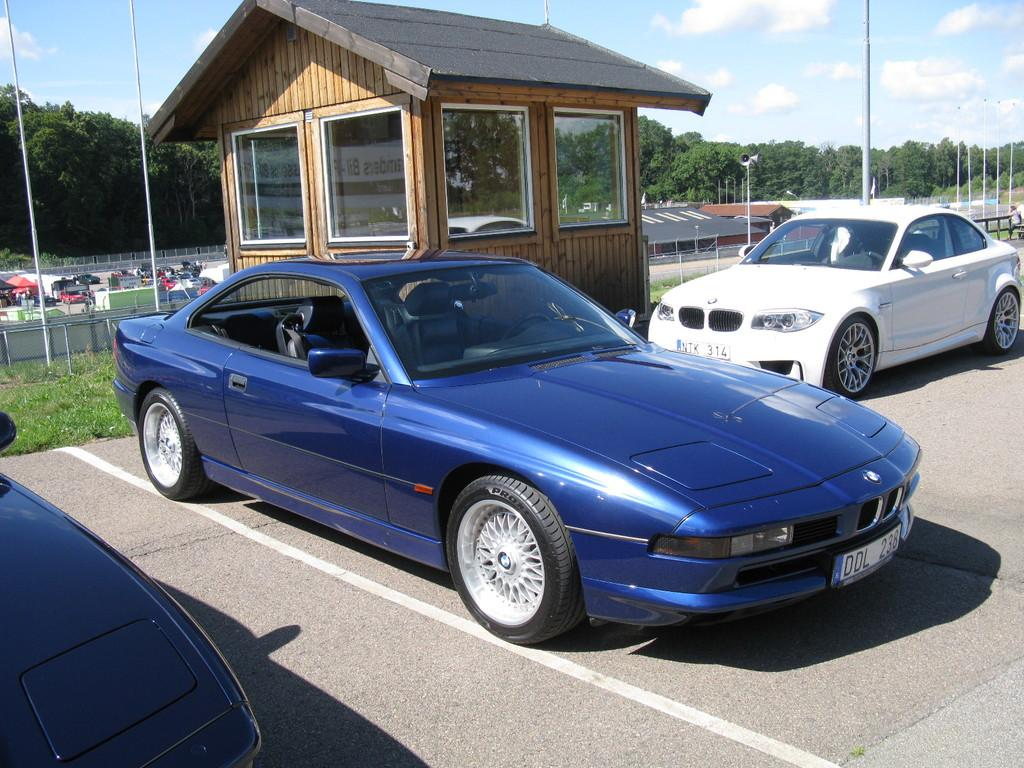What is the main subject in the center of the image? There are cars in the center of the image. What type of ground surface is visible in the image? There is grass on the ground. What can be seen inside the room visible in the image? The information provided does not specify what can be seen inside the room. What else is visible in the background of the image? There are vehicles, poles, and trees in the background of the image. How would you describe the weather in the image? The sky is cloudy in the image. What type of crib is visible in the image? There is no crib present in the image. How does the error in the image affect the functionality of the vehicles? There is no error present in the image, and therefore it cannot affect the functionality of the vehicles. 